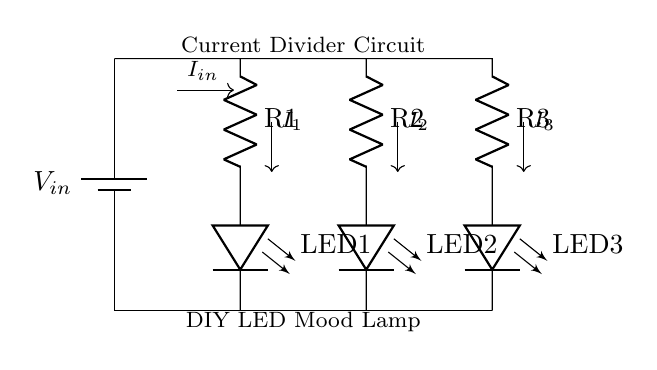What is the input voltage for this circuit? The circuit has a battery symbol labeled as V_in, which indicates that it provides the input voltage. The specific value isn't provided in the diagram, but it is typically marked on the battery in a complete schematic.
Answer: V_in What is the total number of resistors in this circuit? The diagram shows three resistors, R1, R2, and R3, connected in parallel. Each resistor can be identified by its respective label.
Answer: 3 What is the direction of the current flow in this circuit? The current flows from the positive terminal of the battery downwards through the resistors and LEDs to the ground. The diagram indicates this by arrows labeled I_in, I1, I2, and I3, showing the path of current through each component.
Answer: Downwards What type of connection is used for resistors R1, R2, and R3? The resistors in the circuit are connected in parallel, as indicated by their branches stemming from the same voltage level and converging at the output. This means the voltage across each resistor is the same.
Answer: Parallel How does the current divide among the resistors in the circuit? In a current divider, the total current entering the circuit divides inversely proportional to the resistance values. This means a lower resistance will draw more current while a higher resistance will draw less, following the formula I_x = I_in * (R_total / R_x).
Answer: Inversely proportional Which component is used to create visual output in this circuit? The diagram includes three LEDs (LED1, LED2, and LED3) which serve as the visual output component. They are directly connected to the resistors and light up when current flows through them.
Answer: LEDs What is the main purpose of this current divider circuit in the context of the project? In the DIY LED mood lamp project, the current divider circuit allows the simultaneous operation of multiple LEDs with different brightness levels, thus enabling effective mood lighting. This is especially useful for achieving varied light intensities from the LEDs.
Answer: Mood lighting 